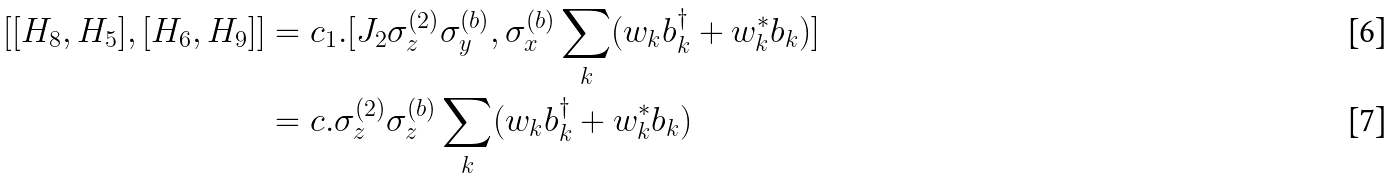<formula> <loc_0><loc_0><loc_500><loc_500>[ [ H _ { 8 } , H _ { 5 } ] , [ H _ { 6 } , H _ { 9 } ] ] & = c _ { 1 } . [ J _ { 2 } \sigma _ { z } ^ { ( 2 ) } \sigma _ { y } ^ { ( b ) } , \sigma _ { x } ^ { ( b ) } \sum _ { k } ( w _ { k } b _ { k } ^ { \dagger } + w _ { k } ^ { * } b _ { k } ) ] \\ & = c . \sigma _ { z } ^ { ( 2 ) } \sigma _ { z } ^ { ( b ) } \sum _ { k } ( w _ { k } b _ { k } ^ { \dagger } + w _ { k } ^ { * } b _ { k } )</formula> 